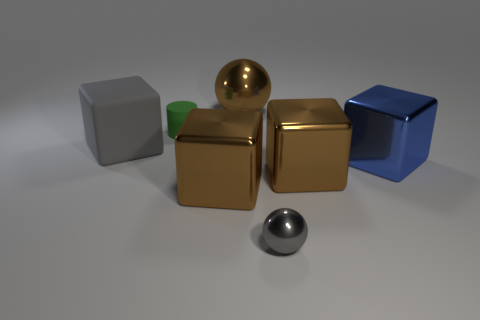What is the material of the thing that is the same color as the small ball?
Your answer should be compact. Rubber. How many objects are either objects to the right of the brown metallic ball or big gray rubber objects?
Your response must be concise. 4. How many things are big brown shiny balls or brown things that are behind the small green object?
Keep it short and to the point. 1. There is a brown metal thing that is in front of the brown thing that is to the right of the gray metal thing; how many small gray things are right of it?
Give a very brief answer. 1. There is a blue thing that is the same size as the gray block; what is it made of?
Offer a very short reply. Metal. Is there a yellow metallic cube of the same size as the green rubber cylinder?
Offer a terse response. No. The large rubber block has what color?
Offer a very short reply. Gray. What color is the small object in front of the rubber object that is on the left side of the small green cylinder?
Your answer should be compact. Gray. What shape is the metal thing on the left side of the ball behind the brown metal block that is left of the big shiny ball?
Your response must be concise. Cube. What number of cylinders are the same material as the big gray object?
Keep it short and to the point. 1. 